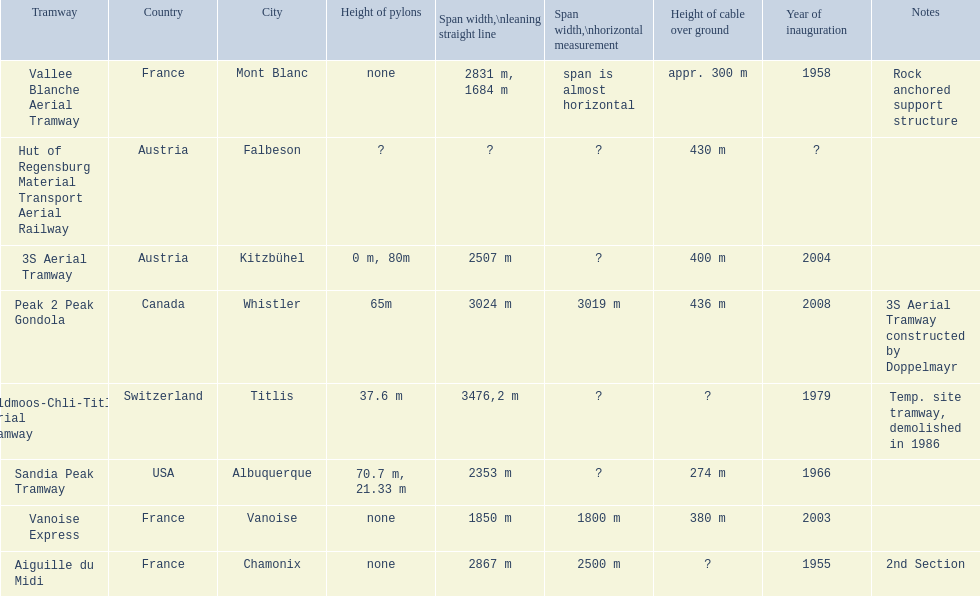Which tramway was inaugurated first, the 3s aerial tramway or the aiguille du midi? Aiguille du Midi. 